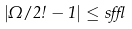<formula> <loc_0><loc_0><loc_500><loc_500>| \Omega / 2 \omega - 1 | \leq s \epsilon</formula> 